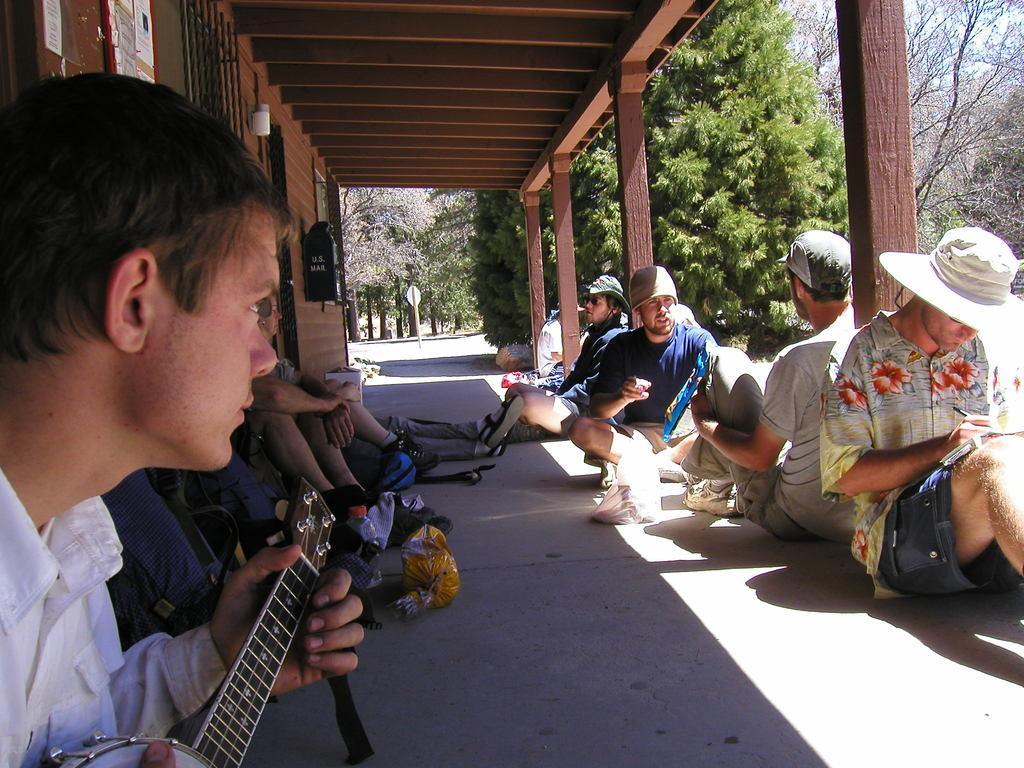In one or two sentences, can you explain what this image depicts? In image i can see a group of people setting, a man holding the guitar and playing,and the man holding the book and writing at the top i can see a wooden roof at the background i can see a tree and a sky. 